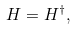Convert formula to latex. <formula><loc_0><loc_0><loc_500><loc_500>H = H ^ { \dag } ,</formula> 